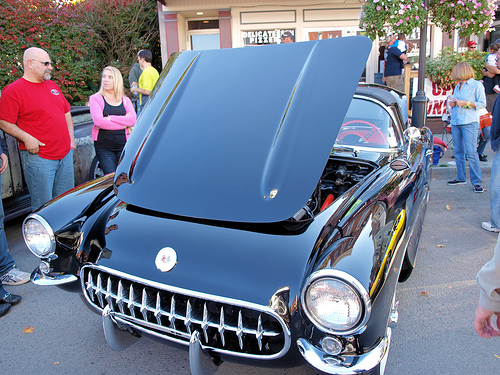<image>
Can you confirm if the woman is on the car? No. The woman is not positioned on the car. They may be near each other, but the woman is not supported by or resting on top of the car. 